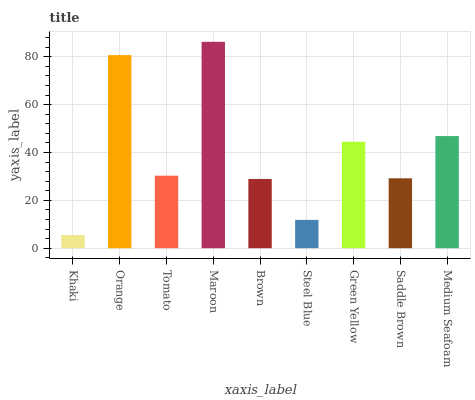Is Khaki the minimum?
Answer yes or no. Yes. Is Maroon the maximum?
Answer yes or no. Yes. Is Orange the minimum?
Answer yes or no. No. Is Orange the maximum?
Answer yes or no. No. Is Orange greater than Khaki?
Answer yes or no. Yes. Is Khaki less than Orange?
Answer yes or no. Yes. Is Khaki greater than Orange?
Answer yes or no. No. Is Orange less than Khaki?
Answer yes or no. No. Is Tomato the high median?
Answer yes or no. Yes. Is Tomato the low median?
Answer yes or no. Yes. Is Saddle Brown the high median?
Answer yes or no. No. Is Saddle Brown the low median?
Answer yes or no. No. 